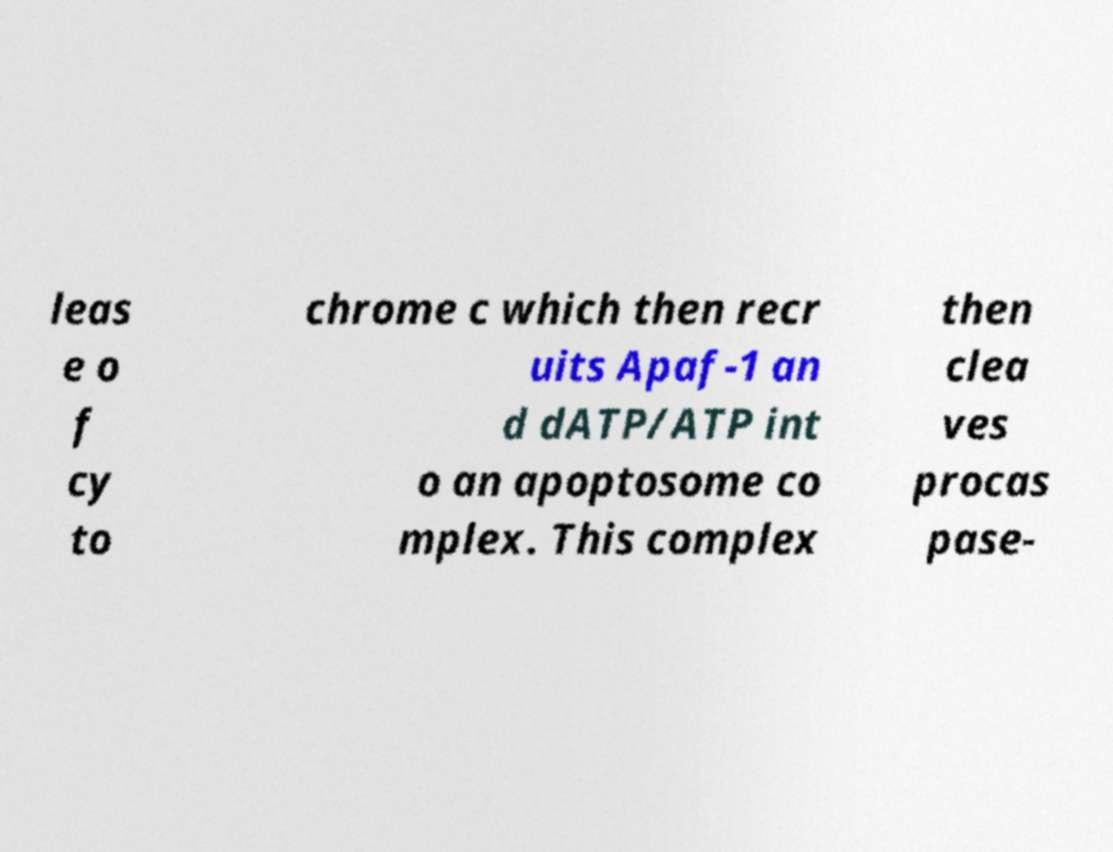Can you accurately transcribe the text from the provided image for me? leas e o f cy to chrome c which then recr uits Apaf-1 an d dATP/ATP int o an apoptosome co mplex. This complex then clea ves procas pase- 